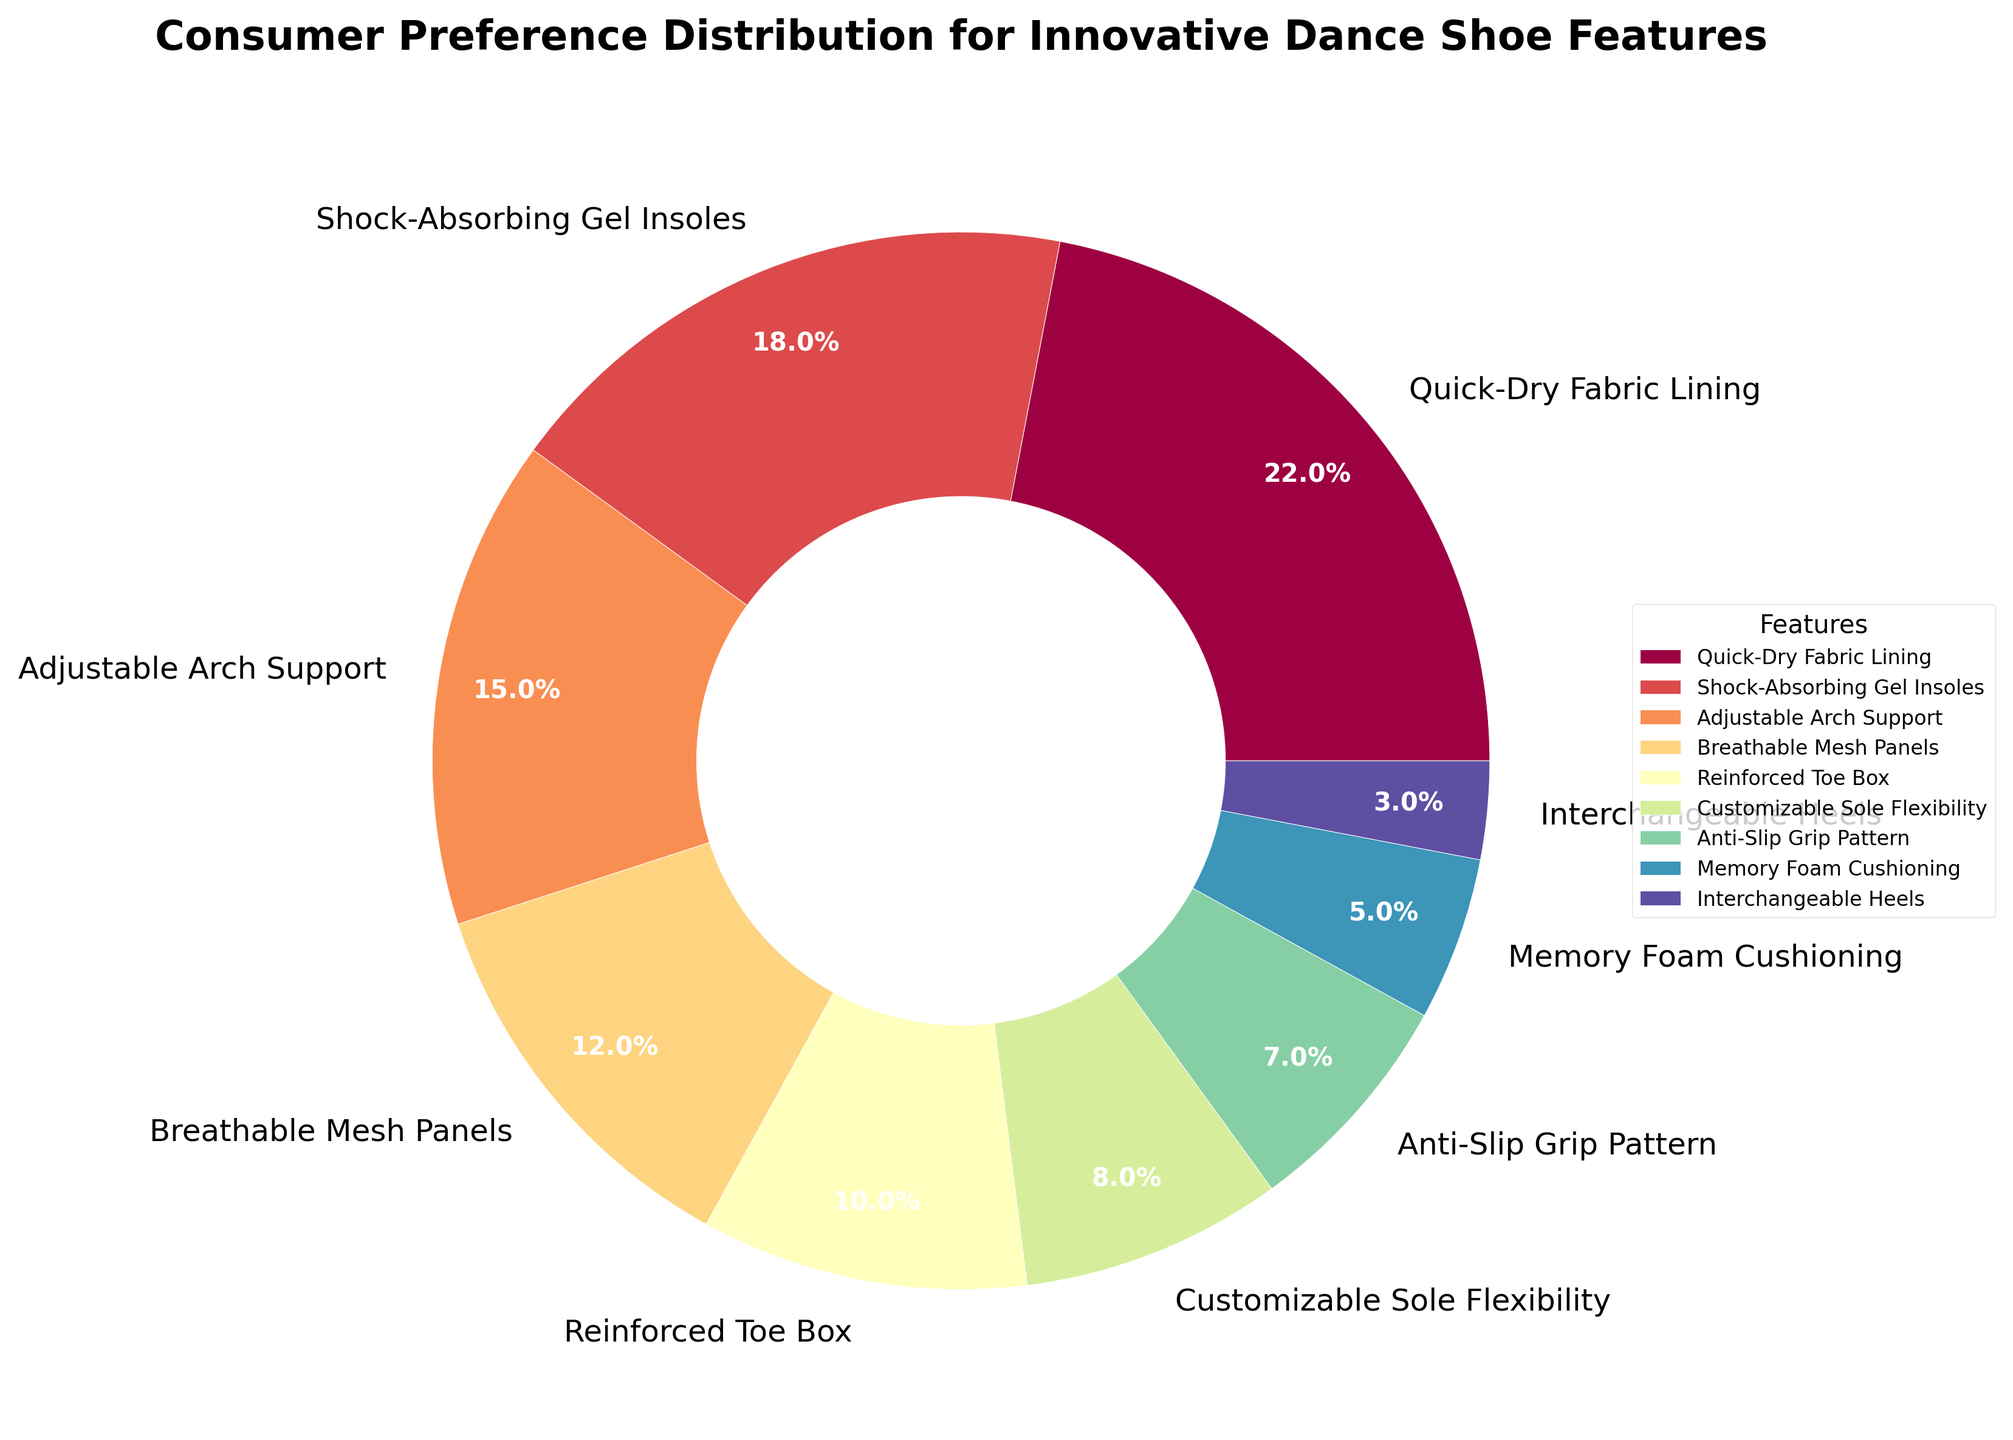What is the most preferred innovative feature in dance shoes according to the pie chart? The 'Quick-Dry Fabric Lining' segment takes up the largest portion of the pie chart, indicating it is the most preferred feature.
Answer: Quick-Dry Fabric Lining Which feature is the least preferred by consumers? The 'Interchangeable Heels' segment takes up the smallest portion of the pie chart, indicating it is the least preferred feature.
Answer: Interchangeable Heels How much more popular is 'Quick-Dry Fabric Lining' compared to 'Anti-Slip Grip Pattern'? The segment for 'Quick-Dry Fabric Lining' shows 22%, while 'Anti-Slip Grip Pattern' shows 7%. The difference is 22% - 7% = 15%.
Answer: 15% What is the combined percentage of consumers preferring 'Breathable Mesh Panels' and 'Reinforced Toe Box'? The percentages for 'Breathable Mesh Panels' and 'Reinforced Toe Box' are 12% and 10%, respectively. Adding them together, 12% + 10% = 22%.
Answer: 22% Which feature ranks third in terms of consumer preference? The third highest percentage is shown by the 'Adjustable Arch Support' segment at 15%.
Answer: Adjustable Arch Support Is 'Memory Foam Cushioning' more preferred than 'Anti-Slip Grip Pattern'? The pie chart shows that 'Memory Foam Cushioning' has 5% while 'Anti-Slip Grip Pattern' has 7%, so 'Memory Foam Cushioning' is less preferred.
Answer: No Which two features have a combined preference of over 30%? The 'Quick-Dry Fabric Lining' and 'Shock-Absorbing Gel Insoles' segments together show 22% + 18% = 40%, which is over 30%.
Answer: Quick-Dry Fabric Lining and Shock-Absorbing Gel Insoles Compare the combined preference of 'Customizable Sole Flexibility' and 'Memory Foam Cushioning' to 'Adjustable Arch Support'. The combined percentage for 'Customizable Sole Flexibility' and 'Memory Foam Cushioning' is 8% + 5% = 13%, which is less than the 15% for 'Adjustable Arch Support'.
Answer: Less What visual clue indicates that 'Shock-Absorbing Gel Insoles' is highly preferred? The large and distinct segment size for 'Shock-Absorbing Gel Insoles' covering 18% of the chart visually indicates its high preference.
Answer: Large segment size How does the preference for 'Reinforced Toe Box' compare to 'Breathable Mesh Panels'? The pie chart shows 'Reinforced Toe Box' at 10% and 'Breathable Mesh Panels' at 12%, so 'Breathable Mesh Panels' is more preferred by 2%.
Answer: Breathable Mesh Panels is more preferred by 2% 